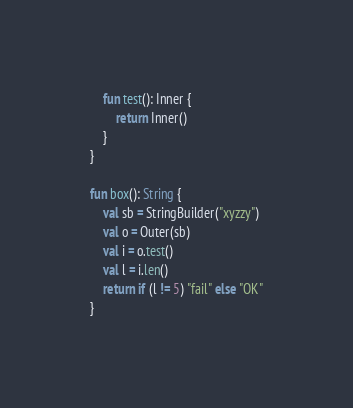<code> <loc_0><loc_0><loc_500><loc_500><_Kotlin_>
    fun test(): Inner {
        return Inner()
    }
}

fun box(): String {
    val sb = StringBuilder("xyzzy")
    val o = Outer(sb)
    val i = o.test()
    val l = i.len()
    return if (l != 5) "fail" else "OK"
}
</code> 